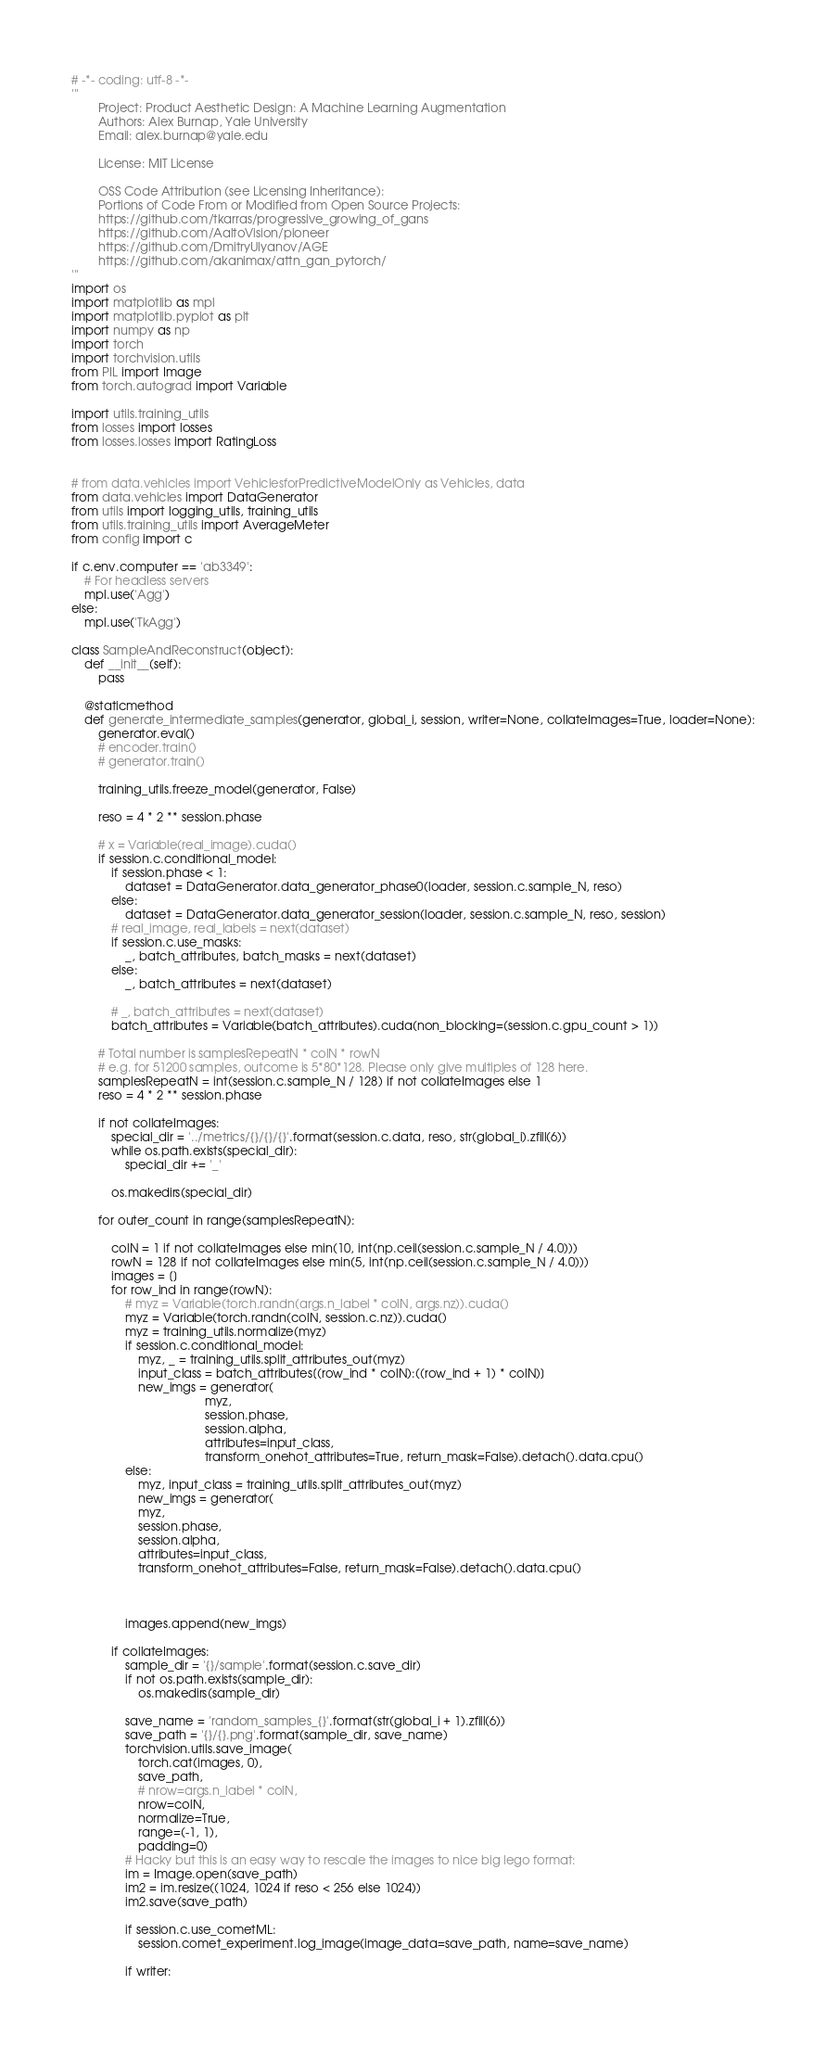Convert code to text. <code><loc_0><loc_0><loc_500><loc_500><_Python_># -*- coding: utf-8 -*-
'''
        Project: Product Aesthetic Design: A Machine Learning Augmentation
        Authors: Alex Burnap, Yale University
        Email: alex.burnap@yale.edu

        License: MIT License

        OSS Code Attribution (see Licensing Inheritance):
        Portions of Code From or Modified from Open Source Projects:
        https://github.com/tkarras/progressive_growing_of_gans
        https://github.com/AaltoVision/pioneer
        https://github.com/DmitryUlyanov/AGE
        https://github.com/akanimax/attn_gan_pytorch/
'''
import os
import matplotlib as mpl
import matplotlib.pyplot as plt
import numpy as np
import torch
import torchvision.utils
from PIL import Image
from torch.autograd import Variable

import utils.training_utils
from losses import losses
from losses.losses import RatingLoss


# from data.vehicles import VehiclesforPredictiveModelOnly as Vehicles, data
from data.vehicles import DataGenerator
from utils import logging_utils, training_utils
from utils.training_utils import AverageMeter
from config import c

if c.env.computer == 'ab3349':
    # For headless servers
    mpl.use('Agg')
else:
    mpl.use('TkAgg')

class SampleAndReconstruct(object):
    def __init__(self):
        pass

    @staticmethod
    def generate_intermediate_samples(generator, global_i, session, writer=None, collateImages=True, loader=None):
        generator.eval()
        # encoder.train()
        # generator.train()

        training_utils.freeze_model(generator, False)

        reso = 4 * 2 ** session.phase

        # x = Variable(real_image).cuda()
        if session.c.conditional_model:
            if session.phase < 1:
                dataset = DataGenerator.data_generator_phase0(loader, session.c.sample_N, reso)
            else:
                dataset = DataGenerator.data_generator_session(loader, session.c.sample_N, reso, session)
            # real_image, real_labels = next(dataset)
            if session.c.use_masks:
                _, batch_attributes, batch_masks = next(dataset)
            else:
                _, batch_attributes = next(dataset)

            # _, batch_attributes = next(dataset)
            batch_attributes = Variable(batch_attributes).cuda(non_blocking=(session.c.gpu_count > 1))

        # Total number is samplesRepeatN * colN * rowN
        # e.g. for 51200 samples, outcome is 5*80*128. Please only give multiples of 128 here.
        samplesRepeatN = int(session.c.sample_N / 128) if not collateImages else 1
        reso = 4 * 2 ** session.phase

        if not collateImages:
            special_dir = '../metrics/{}/{}/{}'.format(session.c.data, reso, str(global_i).zfill(6))
            while os.path.exists(special_dir):
                special_dir += '_'

            os.makedirs(special_dir)

        for outer_count in range(samplesRepeatN):

            colN = 1 if not collateImages else min(10, int(np.ceil(session.c.sample_N / 4.0)))
            rowN = 128 if not collateImages else min(5, int(np.ceil(session.c.sample_N / 4.0)))
            images = []
            for row_ind in range(rowN):
                # myz = Variable(torch.randn(args.n_label * colN, args.nz)).cuda()
                myz = Variable(torch.randn(colN, session.c.nz)).cuda()
                myz = training_utils.normalize(myz)
                if session.c.conditional_model:
                    myz, _ = training_utils.split_attributes_out(myz)
                    input_class = batch_attributes[(row_ind * colN):((row_ind + 1) * colN)]
                    new_imgs = generator(
                                        myz,
                                        session.phase,
                                        session.alpha,
                                        attributes=input_class,
                                        transform_onehot_attributes=True, return_mask=False).detach().data.cpu()
                else:
                    myz, input_class = training_utils.split_attributes_out(myz)
                    new_imgs = generator(
                    myz,
                    session.phase,
                    session.alpha,
                    attributes=input_class,
                    transform_onehot_attributes=False, return_mask=False).detach().data.cpu()

                

                images.append(new_imgs)

            if collateImages:
                sample_dir = '{}/sample'.format(session.c.save_dir)
                if not os.path.exists(sample_dir):
                    os.makedirs(sample_dir)

                save_name = 'random_samples_{}'.format(str(global_i + 1).zfill(6))
                save_path = '{}/{}.png'.format(sample_dir, save_name)
                torchvision.utils.save_image(
                    torch.cat(images, 0),
                    save_path,
                    # nrow=args.n_label * colN,
                    nrow=colN,
                    normalize=True,
                    range=(-1, 1),
                    padding=0)
                # Hacky but this is an easy way to rescale the images to nice big lego format:
                im = Image.open(save_path)
                im2 = im.resize((1024, 1024 if reso < 256 else 1024))
                im2.save(save_path)

                if session.c.use_cometML:
                    session.comet_experiment.log_image(image_data=save_path, name=save_name)

                if writer:</code> 